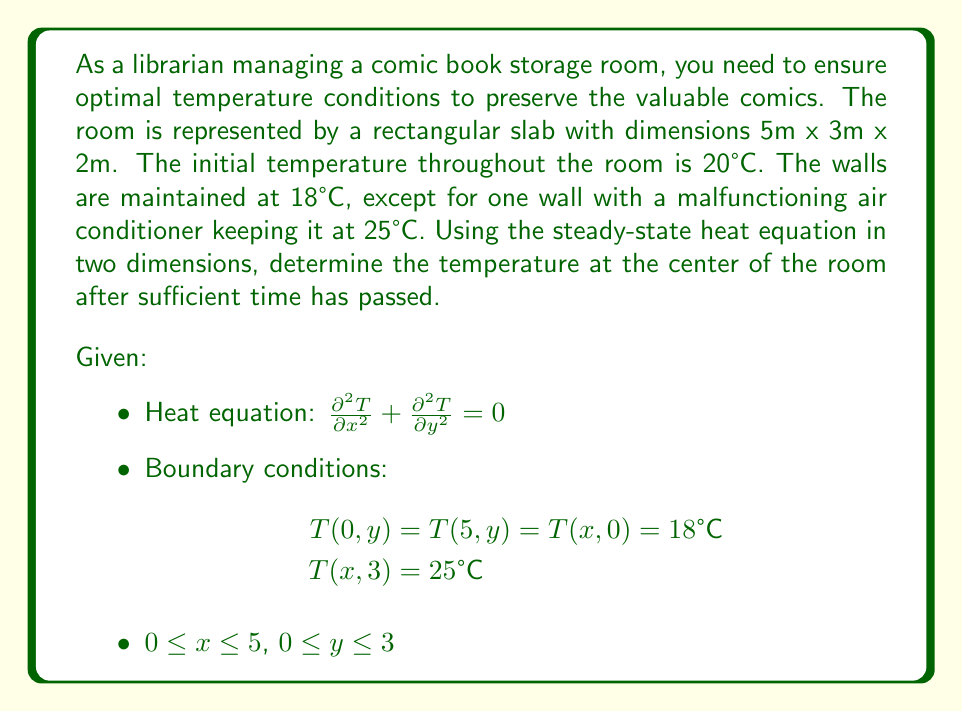Teach me how to tackle this problem. To solve this problem, we'll use the method of separation of variables for the 2D steady-state heat equation.

1) Assume the solution has the form: $T(x,y) = X(x)Y(y)$

2) Substituting into the heat equation:
   $$Y\frac{d^2X}{dx^2} + X\frac{d^2Y}{dy^2} = 0$$

3) Dividing by XY:
   $$\frac{1}{X}\frac{d^2X}{dx^2} = -\frac{1}{Y}\frac{d^2Y}{dy^2} = -\lambda^2$$

4) This gives us two ODEs:
   $$\frac{d^2X}{dx^2} + \lambda^2X = 0$$
   $$\frac{d^2Y}{dy^2} - \lambda^2Y = 0$$

5) The general solutions are:
   $$X(x) = A\cos(\lambda x) + B\sin(\lambda x)$$
   $$Y(y) = C\cosh(\lambda y) + D\sinh(\lambda y)$$

6) Applying the boundary conditions:
   T(0,y) = T(5,y) = 18°C implies $\lambda = \frac{n\pi}{5}$ where n is an odd integer.

7) The complete solution is:
   $$T(x,y) = 18 + \sum_{n=1,3,5...}^\infty A_n \sin(\frac{n\pi x}{5})[\sinh(\frac{n\pi y}{5}) + B_n\cosh(\frac{n\pi y}{5})]$$

8) Using the remaining boundary conditions to determine $A_n$ and $B_n$:
   $$A_n = \frac{14}{\sinh(3n\pi/5)}$$
   $$B_n = -\coth(3n\pi/5)$$

9) The temperature at the center (2.5, 1.5) is:
   $$T(2.5, 1.5) = 18 + \sum_{n=1,3,5...}^\infty \frac{14}{\sinh(3n\pi/5)} \sin(\frac{n\pi}{2})[\sinh(\frac{3n\pi}{10}) - \cosh(\frac{3n\pi}{10})\coth(3n\pi/5)]$$

10) Evaluating this series numerically (using software or a calculator), we find:
    $$T(2.5, 1.5) \approx 20.76°C$$
Answer: 20.76°C 